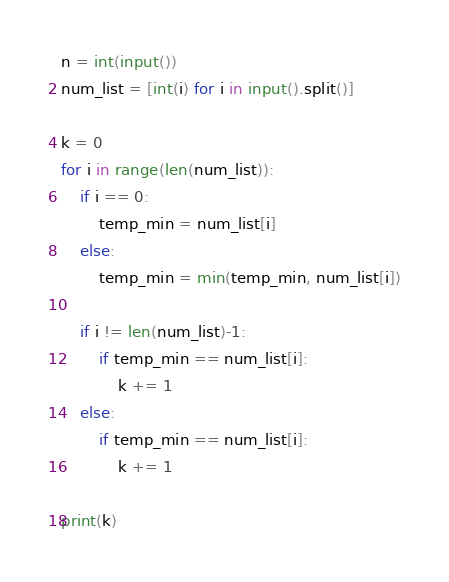Convert code to text. <code><loc_0><loc_0><loc_500><loc_500><_Python_>n = int(input())
num_list = [int(i) for i in input().split()]

k = 0
for i in range(len(num_list)):
    if i == 0:
        temp_min = num_list[i]
    else:
        temp_min = min(temp_min, num_list[i])
        
    if i != len(num_list)-1:
        if temp_min == num_list[i]:
            k += 1
    else:
        if temp_min == num_list[i]:
            k += 1
    
print(k)</code> 